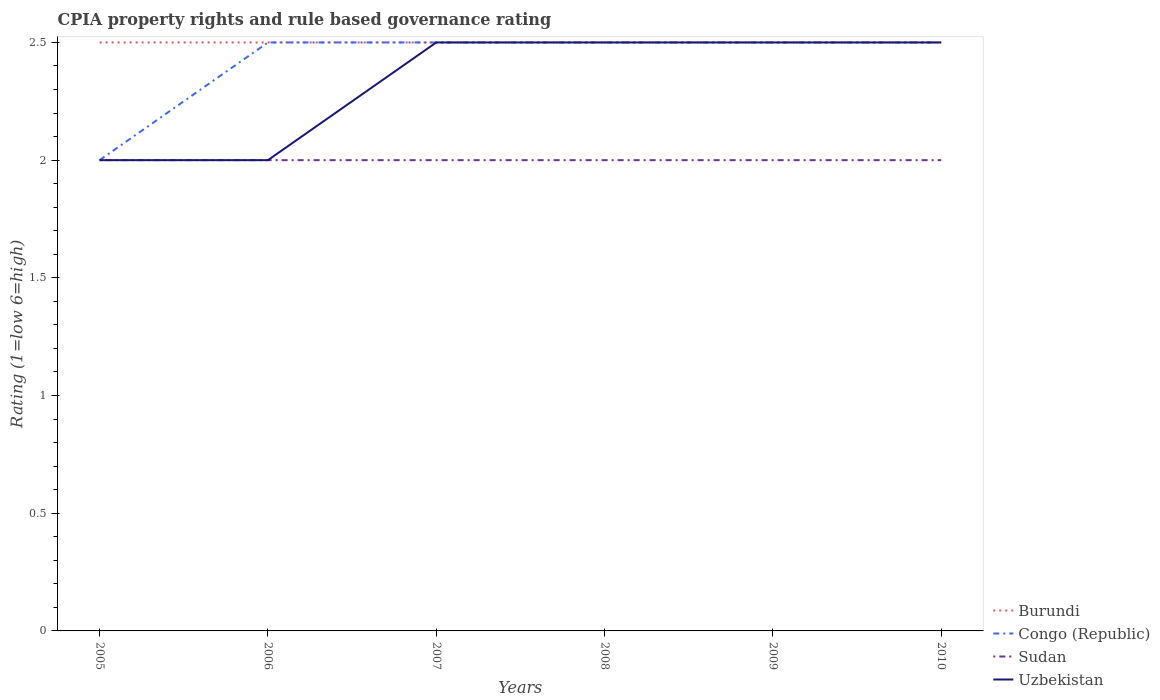Is the number of lines equal to the number of legend labels?
Provide a succinct answer. Yes. Across all years, what is the maximum CPIA rating in Uzbekistan?
Keep it short and to the point. 2. What is the total CPIA rating in Sudan in the graph?
Your answer should be compact. 0. What is the difference between the highest and the second highest CPIA rating in Burundi?
Give a very brief answer. 0. Is the CPIA rating in Uzbekistan strictly greater than the CPIA rating in Sudan over the years?
Your answer should be very brief. No. Does the graph contain any zero values?
Give a very brief answer. No. How are the legend labels stacked?
Ensure brevity in your answer.  Vertical. What is the title of the graph?
Give a very brief answer. CPIA property rights and rule based governance rating. Does "Israel" appear as one of the legend labels in the graph?
Make the answer very short. No. What is the Rating (1=low 6=high) of Congo (Republic) in 2005?
Your answer should be compact. 2. What is the Rating (1=low 6=high) in Sudan in 2006?
Ensure brevity in your answer.  2. What is the Rating (1=low 6=high) of Burundi in 2007?
Ensure brevity in your answer.  2.5. What is the Rating (1=low 6=high) in Sudan in 2007?
Keep it short and to the point. 2. What is the Rating (1=low 6=high) of Congo (Republic) in 2008?
Provide a short and direct response. 2.5. What is the Rating (1=low 6=high) of Sudan in 2008?
Your response must be concise. 2. What is the Rating (1=low 6=high) of Burundi in 2009?
Make the answer very short. 2.5. What is the Rating (1=low 6=high) in Sudan in 2009?
Your response must be concise. 2. What is the Rating (1=low 6=high) in Uzbekistan in 2009?
Keep it short and to the point. 2.5. Across all years, what is the maximum Rating (1=low 6=high) of Congo (Republic)?
Offer a terse response. 2.5. Across all years, what is the maximum Rating (1=low 6=high) of Uzbekistan?
Make the answer very short. 2.5. Across all years, what is the minimum Rating (1=low 6=high) in Burundi?
Give a very brief answer. 2.5. Across all years, what is the minimum Rating (1=low 6=high) of Sudan?
Ensure brevity in your answer.  2. Across all years, what is the minimum Rating (1=low 6=high) of Uzbekistan?
Your answer should be very brief. 2. What is the total Rating (1=low 6=high) of Burundi in the graph?
Your answer should be very brief. 15. What is the total Rating (1=low 6=high) in Sudan in the graph?
Your answer should be compact. 12. What is the difference between the Rating (1=low 6=high) of Burundi in 2005 and that in 2006?
Provide a succinct answer. 0. What is the difference between the Rating (1=low 6=high) of Congo (Republic) in 2005 and that in 2006?
Your answer should be compact. -0.5. What is the difference between the Rating (1=low 6=high) in Uzbekistan in 2005 and that in 2006?
Ensure brevity in your answer.  0. What is the difference between the Rating (1=low 6=high) in Sudan in 2005 and that in 2007?
Give a very brief answer. 0. What is the difference between the Rating (1=low 6=high) in Uzbekistan in 2005 and that in 2007?
Ensure brevity in your answer.  -0.5. What is the difference between the Rating (1=low 6=high) in Burundi in 2005 and that in 2008?
Make the answer very short. 0. What is the difference between the Rating (1=low 6=high) of Sudan in 2005 and that in 2008?
Provide a short and direct response. 0. What is the difference between the Rating (1=low 6=high) of Uzbekistan in 2005 and that in 2008?
Provide a succinct answer. -0.5. What is the difference between the Rating (1=low 6=high) of Uzbekistan in 2005 and that in 2009?
Give a very brief answer. -0.5. What is the difference between the Rating (1=low 6=high) of Sudan in 2005 and that in 2010?
Provide a short and direct response. 0. What is the difference between the Rating (1=low 6=high) in Uzbekistan in 2005 and that in 2010?
Keep it short and to the point. -0.5. What is the difference between the Rating (1=low 6=high) of Congo (Republic) in 2006 and that in 2007?
Offer a terse response. 0. What is the difference between the Rating (1=low 6=high) of Burundi in 2006 and that in 2008?
Your response must be concise. 0. What is the difference between the Rating (1=low 6=high) in Congo (Republic) in 2006 and that in 2009?
Offer a terse response. 0. What is the difference between the Rating (1=low 6=high) in Sudan in 2006 and that in 2010?
Ensure brevity in your answer.  0. What is the difference between the Rating (1=low 6=high) in Uzbekistan in 2006 and that in 2010?
Offer a terse response. -0.5. What is the difference between the Rating (1=low 6=high) in Burundi in 2007 and that in 2008?
Offer a terse response. 0. What is the difference between the Rating (1=low 6=high) in Congo (Republic) in 2007 and that in 2008?
Your response must be concise. 0. What is the difference between the Rating (1=low 6=high) of Sudan in 2007 and that in 2008?
Your response must be concise. 0. What is the difference between the Rating (1=low 6=high) in Uzbekistan in 2007 and that in 2008?
Keep it short and to the point. 0. What is the difference between the Rating (1=low 6=high) of Sudan in 2007 and that in 2009?
Offer a terse response. 0. What is the difference between the Rating (1=low 6=high) of Uzbekistan in 2007 and that in 2009?
Keep it short and to the point. 0. What is the difference between the Rating (1=low 6=high) of Burundi in 2007 and that in 2010?
Provide a succinct answer. 0. What is the difference between the Rating (1=low 6=high) in Congo (Republic) in 2007 and that in 2010?
Keep it short and to the point. 0. What is the difference between the Rating (1=low 6=high) of Sudan in 2007 and that in 2010?
Ensure brevity in your answer.  0. What is the difference between the Rating (1=low 6=high) in Uzbekistan in 2007 and that in 2010?
Offer a very short reply. 0. What is the difference between the Rating (1=low 6=high) in Sudan in 2008 and that in 2009?
Your response must be concise. 0. What is the difference between the Rating (1=low 6=high) of Congo (Republic) in 2008 and that in 2010?
Your answer should be compact. 0. What is the difference between the Rating (1=low 6=high) of Uzbekistan in 2008 and that in 2010?
Keep it short and to the point. 0. What is the difference between the Rating (1=low 6=high) of Burundi in 2009 and that in 2010?
Offer a very short reply. 0. What is the difference between the Rating (1=low 6=high) of Congo (Republic) in 2009 and that in 2010?
Give a very brief answer. 0. What is the difference between the Rating (1=low 6=high) in Uzbekistan in 2009 and that in 2010?
Keep it short and to the point. 0. What is the difference between the Rating (1=low 6=high) in Burundi in 2005 and the Rating (1=low 6=high) in Congo (Republic) in 2006?
Make the answer very short. 0. What is the difference between the Rating (1=low 6=high) of Burundi in 2005 and the Rating (1=low 6=high) of Uzbekistan in 2006?
Ensure brevity in your answer.  0.5. What is the difference between the Rating (1=low 6=high) in Congo (Republic) in 2005 and the Rating (1=low 6=high) in Sudan in 2006?
Make the answer very short. 0. What is the difference between the Rating (1=low 6=high) in Congo (Republic) in 2005 and the Rating (1=low 6=high) in Uzbekistan in 2006?
Make the answer very short. 0. What is the difference between the Rating (1=low 6=high) in Sudan in 2005 and the Rating (1=low 6=high) in Uzbekistan in 2006?
Your answer should be compact. 0. What is the difference between the Rating (1=low 6=high) in Burundi in 2005 and the Rating (1=low 6=high) in Congo (Republic) in 2007?
Keep it short and to the point. 0. What is the difference between the Rating (1=low 6=high) of Burundi in 2005 and the Rating (1=low 6=high) of Sudan in 2007?
Make the answer very short. 0.5. What is the difference between the Rating (1=low 6=high) of Burundi in 2005 and the Rating (1=low 6=high) of Uzbekistan in 2007?
Provide a succinct answer. 0. What is the difference between the Rating (1=low 6=high) in Congo (Republic) in 2005 and the Rating (1=low 6=high) in Sudan in 2007?
Provide a short and direct response. 0. What is the difference between the Rating (1=low 6=high) in Congo (Republic) in 2005 and the Rating (1=low 6=high) in Uzbekistan in 2007?
Ensure brevity in your answer.  -0.5. What is the difference between the Rating (1=low 6=high) of Burundi in 2005 and the Rating (1=low 6=high) of Congo (Republic) in 2009?
Your response must be concise. 0. What is the difference between the Rating (1=low 6=high) in Sudan in 2005 and the Rating (1=low 6=high) in Uzbekistan in 2009?
Offer a very short reply. -0.5. What is the difference between the Rating (1=low 6=high) in Burundi in 2005 and the Rating (1=low 6=high) in Congo (Republic) in 2010?
Your response must be concise. 0. What is the difference between the Rating (1=low 6=high) of Burundi in 2005 and the Rating (1=low 6=high) of Sudan in 2010?
Make the answer very short. 0.5. What is the difference between the Rating (1=low 6=high) of Sudan in 2005 and the Rating (1=low 6=high) of Uzbekistan in 2010?
Your answer should be very brief. -0.5. What is the difference between the Rating (1=low 6=high) of Congo (Republic) in 2006 and the Rating (1=low 6=high) of Uzbekistan in 2007?
Make the answer very short. 0. What is the difference between the Rating (1=low 6=high) of Burundi in 2006 and the Rating (1=low 6=high) of Sudan in 2008?
Your answer should be very brief. 0.5. What is the difference between the Rating (1=low 6=high) of Burundi in 2006 and the Rating (1=low 6=high) of Uzbekistan in 2008?
Make the answer very short. 0. What is the difference between the Rating (1=low 6=high) in Congo (Republic) in 2006 and the Rating (1=low 6=high) in Uzbekistan in 2008?
Give a very brief answer. 0. What is the difference between the Rating (1=low 6=high) of Sudan in 2006 and the Rating (1=low 6=high) of Uzbekistan in 2008?
Your answer should be compact. -0.5. What is the difference between the Rating (1=low 6=high) in Congo (Republic) in 2006 and the Rating (1=low 6=high) in Sudan in 2009?
Give a very brief answer. 0.5. What is the difference between the Rating (1=low 6=high) in Congo (Republic) in 2006 and the Rating (1=low 6=high) in Uzbekistan in 2009?
Provide a short and direct response. 0. What is the difference between the Rating (1=low 6=high) in Congo (Republic) in 2006 and the Rating (1=low 6=high) in Sudan in 2010?
Make the answer very short. 0.5. What is the difference between the Rating (1=low 6=high) of Congo (Republic) in 2006 and the Rating (1=low 6=high) of Uzbekistan in 2010?
Offer a very short reply. 0. What is the difference between the Rating (1=low 6=high) of Burundi in 2007 and the Rating (1=low 6=high) of Congo (Republic) in 2008?
Offer a terse response. 0. What is the difference between the Rating (1=low 6=high) in Burundi in 2007 and the Rating (1=low 6=high) in Sudan in 2008?
Your answer should be very brief. 0.5. What is the difference between the Rating (1=low 6=high) of Burundi in 2007 and the Rating (1=low 6=high) of Uzbekistan in 2008?
Give a very brief answer. 0. What is the difference between the Rating (1=low 6=high) in Congo (Republic) in 2007 and the Rating (1=low 6=high) in Sudan in 2008?
Give a very brief answer. 0.5. What is the difference between the Rating (1=low 6=high) of Congo (Republic) in 2007 and the Rating (1=low 6=high) of Uzbekistan in 2008?
Give a very brief answer. 0. What is the difference between the Rating (1=low 6=high) of Sudan in 2007 and the Rating (1=low 6=high) of Uzbekistan in 2008?
Ensure brevity in your answer.  -0.5. What is the difference between the Rating (1=low 6=high) of Burundi in 2007 and the Rating (1=low 6=high) of Congo (Republic) in 2009?
Offer a terse response. 0. What is the difference between the Rating (1=low 6=high) in Burundi in 2007 and the Rating (1=low 6=high) in Sudan in 2009?
Give a very brief answer. 0.5. What is the difference between the Rating (1=low 6=high) in Burundi in 2007 and the Rating (1=low 6=high) in Uzbekistan in 2009?
Your answer should be very brief. 0. What is the difference between the Rating (1=low 6=high) in Congo (Republic) in 2007 and the Rating (1=low 6=high) in Sudan in 2009?
Make the answer very short. 0.5. What is the difference between the Rating (1=low 6=high) in Congo (Republic) in 2007 and the Rating (1=low 6=high) in Uzbekistan in 2009?
Provide a short and direct response. 0. What is the difference between the Rating (1=low 6=high) of Burundi in 2007 and the Rating (1=low 6=high) of Congo (Republic) in 2010?
Offer a terse response. 0. What is the difference between the Rating (1=low 6=high) in Burundi in 2007 and the Rating (1=low 6=high) in Sudan in 2010?
Provide a short and direct response. 0.5. What is the difference between the Rating (1=low 6=high) of Burundi in 2007 and the Rating (1=low 6=high) of Uzbekistan in 2010?
Your answer should be very brief. 0. What is the difference between the Rating (1=low 6=high) in Congo (Republic) in 2007 and the Rating (1=low 6=high) in Uzbekistan in 2010?
Provide a short and direct response. 0. What is the difference between the Rating (1=low 6=high) of Sudan in 2007 and the Rating (1=low 6=high) of Uzbekistan in 2010?
Give a very brief answer. -0.5. What is the difference between the Rating (1=low 6=high) in Burundi in 2008 and the Rating (1=low 6=high) in Sudan in 2009?
Offer a terse response. 0.5. What is the difference between the Rating (1=low 6=high) in Sudan in 2008 and the Rating (1=low 6=high) in Uzbekistan in 2009?
Provide a succinct answer. -0.5. What is the difference between the Rating (1=low 6=high) in Burundi in 2008 and the Rating (1=low 6=high) in Sudan in 2010?
Ensure brevity in your answer.  0.5. What is the difference between the Rating (1=low 6=high) of Burundi in 2008 and the Rating (1=low 6=high) of Uzbekistan in 2010?
Keep it short and to the point. 0. What is the difference between the Rating (1=low 6=high) in Congo (Republic) in 2008 and the Rating (1=low 6=high) in Sudan in 2010?
Keep it short and to the point. 0.5. What is the difference between the Rating (1=low 6=high) in Congo (Republic) in 2008 and the Rating (1=low 6=high) in Uzbekistan in 2010?
Make the answer very short. 0. What is the difference between the Rating (1=low 6=high) in Sudan in 2008 and the Rating (1=low 6=high) in Uzbekistan in 2010?
Ensure brevity in your answer.  -0.5. What is the difference between the Rating (1=low 6=high) in Burundi in 2009 and the Rating (1=low 6=high) in Congo (Republic) in 2010?
Your response must be concise. 0. What is the difference between the Rating (1=low 6=high) in Congo (Republic) in 2009 and the Rating (1=low 6=high) in Sudan in 2010?
Give a very brief answer. 0.5. What is the difference between the Rating (1=low 6=high) of Sudan in 2009 and the Rating (1=low 6=high) of Uzbekistan in 2010?
Your answer should be very brief. -0.5. What is the average Rating (1=low 6=high) of Congo (Republic) per year?
Provide a short and direct response. 2.42. What is the average Rating (1=low 6=high) in Uzbekistan per year?
Offer a terse response. 2.33. In the year 2005, what is the difference between the Rating (1=low 6=high) in Burundi and Rating (1=low 6=high) in Congo (Republic)?
Offer a terse response. 0.5. In the year 2005, what is the difference between the Rating (1=low 6=high) of Congo (Republic) and Rating (1=low 6=high) of Sudan?
Offer a very short reply. 0. In the year 2006, what is the difference between the Rating (1=low 6=high) of Congo (Republic) and Rating (1=low 6=high) of Sudan?
Your answer should be very brief. 0.5. In the year 2006, what is the difference between the Rating (1=low 6=high) of Sudan and Rating (1=low 6=high) of Uzbekistan?
Your answer should be very brief. 0. In the year 2007, what is the difference between the Rating (1=low 6=high) of Burundi and Rating (1=low 6=high) of Sudan?
Make the answer very short. 0.5. In the year 2007, what is the difference between the Rating (1=low 6=high) of Burundi and Rating (1=low 6=high) of Uzbekistan?
Keep it short and to the point. 0. In the year 2007, what is the difference between the Rating (1=low 6=high) in Congo (Republic) and Rating (1=low 6=high) in Sudan?
Offer a very short reply. 0.5. In the year 2007, what is the difference between the Rating (1=low 6=high) of Sudan and Rating (1=low 6=high) of Uzbekistan?
Offer a very short reply. -0.5. In the year 2008, what is the difference between the Rating (1=low 6=high) in Burundi and Rating (1=low 6=high) in Sudan?
Offer a very short reply. 0.5. In the year 2008, what is the difference between the Rating (1=low 6=high) of Burundi and Rating (1=low 6=high) of Uzbekistan?
Give a very brief answer. 0. In the year 2008, what is the difference between the Rating (1=low 6=high) in Congo (Republic) and Rating (1=low 6=high) in Uzbekistan?
Your answer should be very brief. 0. In the year 2009, what is the difference between the Rating (1=low 6=high) in Burundi and Rating (1=low 6=high) in Congo (Republic)?
Keep it short and to the point. 0. In the year 2009, what is the difference between the Rating (1=low 6=high) of Burundi and Rating (1=low 6=high) of Sudan?
Provide a short and direct response. 0.5. In the year 2010, what is the difference between the Rating (1=low 6=high) of Burundi and Rating (1=low 6=high) of Congo (Republic)?
Your answer should be very brief. 0. In the year 2010, what is the difference between the Rating (1=low 6=high) of Burundi and Rating (1=low 6=high) of Sudan?
Your answer should be compact. 0.5. What is the ratio of the Rating (1=low 6=high) of Burundi in 2005 to that in 2007?
Ensure brevity in your answer.  1. What is the ratio of the Rating (1=low 6=high) of Congo (Republic) in 2005 to that in 2007?
Your answer should be very brief. 0.8. What is the ratio of the Rating (1=low 6=high) in Sudan in 2005 to that in 2007?
Your answer should be very brief. 1. What is the ratio of the Rating (1=low 6=high) of Congo (Republic) in 2005 to that in 2008?
Your response must be concise. 0.8. What is the ratio of the Rating (1=low 6=high) of Sudan in 2005 to that in 2008?
Offer a terse response. 1. What is the ratio of the Rating (1=low 6=high) in Burundi in 2005 to that in 2009?
Ensure brevity in your answer.  1. What is the ratio of the Rating (1=low 6=high) in Sudan in 2005 to that in 2009?
Ensure brevity in your answer.  1. What is the ratio of the Rating (1=low 6=high) of Uzbekistan in 2005 to that in 2009?
Make the answer very short. 0.8. What is the ratio of the Rating (1=low 6=high) of Congo (Republic) in 2005 to that in 2010?
Keep it short and to the point. 0.8. What is the ratio of the Rating (1=low 6=high) of Sudan in 2005 to that in 2010?
Offer a terse response. 1. What is the ratio of the Rating (1=low 6=high) in Uzbekistan in 2005 to that in 2010?
Your answer should be compact. 0.8. What is the ratio of the Rating (1=low 6=high) of Congo (Republic) in 2006 to that in 2007?
Your answer should be compact. 1. What is the ratio of the Rating (1=low 6=high) of Burundi in 2006 to that in 2008?
Your answer should be very brief. 1. What is the ratio of the Rating (1=low 6=high) of Uzbekistan in 2006 to that in 2008?
Your answer should be compact. 0.8. What is the ratio of the Rating (1=low 6=high) in Congo (Republic) in 2006 to that in 2009?
Offer a terse response. 1. What is the ratio of the Rating (1=low 6=high) of Sudan in 2006 to that in 2009?
Offer a terse response. 1. What is the ratio of the Rating (1=low 6=high) of Congo (Republic) in 2006 to that in 2010?
Your answer should be compact. 1. What is the ratio of the Rating (1=low 6=high) in Burundi in 2007 to that in 2008?
Provide a short and direct response. 1. What is the ratio of the Rating (1=low 6=high) of Sudan in 2007 to that in 2008?
Provide a short and direct response. 1. What is the ratio of the Rating (1=low 6=high) of Burundi in 2007 to that in 2009?
Offer a very short reply. 1. What is the ratio of the Rating (1=low 6=high) in Congo (Republic) in 2007 to that in 2009?
Ensure brevity in your answer.  1. What is the ratio of the Rating (1=low 6=high) in Sudan in 2007 to that in 2009?
Your answer should be very brief. 1. What is the ratio of the Rating (1=low 6=high) in Uzbekistan in 2007 to that in 2009?
Make the answer very short. 1. What is the ratio of the Rating (1=low 6=high) of Congo (Republic) in 2007 to that in 2010?
Offer a terse response. 1. What is the ratio of the Rating (1=low 6=high) of Uzbekistan in 2007 to that in 2010?
Offer a very short reply. 1. What is the ratio of the Rating (1=low 6=high) in Congo (Republic) in 2008 to that in 2009?
Keep it short and to the point. 1. What is the ratio of the Rating (1=low 6=high) in Burundi in 2008 to that in 2010?
Your response must be concise. 1. What is the ratio of the Rating (1=low 6=high) in Sudan in 2008 to that in 2010?
Give a very brief answer. 1. What is the ratio of the Rating (1=low 6=high) of Congo (Republic) in 2009 to that in 2010?
Offer a very short reply. 1. What is the difference between the highest and the second highest Rating (1=low 6=high) in Congo (Republic)?
Offer a very short reply. 0. What is the difference between the highest and the second highest Rating (1=low 6=high) in Sudan?
Offer a very short reply. 0. What is the difference between the highest and the second highest Rating (1=low 6=high) in Uzbekistan?
Your answer should be compact. 0. What is the difference between the highest and the lowest Rating (1=low 6=high) in Burundi?
Offer a very short reply. 0. What is the difference between the highest and the lowest Rating (1=low 6=high) in Congo (Republic)?
Keep it short and to the point. 0.5. What is the difference between the highest and the lowest Rating (1=low 6=high) of Sudan?
Provide a succinct answer. 0. What is the difference between the highest and the lowest Rating (1=low 6=high) in Uzbekistan?
Make the answer very short. 0.5. 